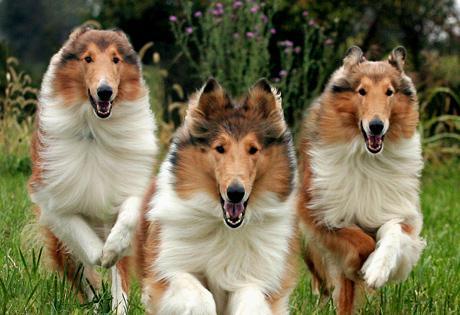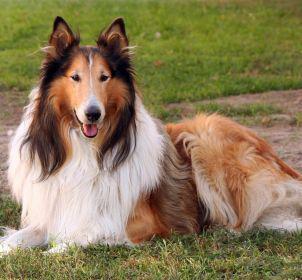The first image is the image on the left, the second image is the image on the right. Considering the images on both sides, is "The dogs on the left are running." valid? Answer yes or no. Yes. 